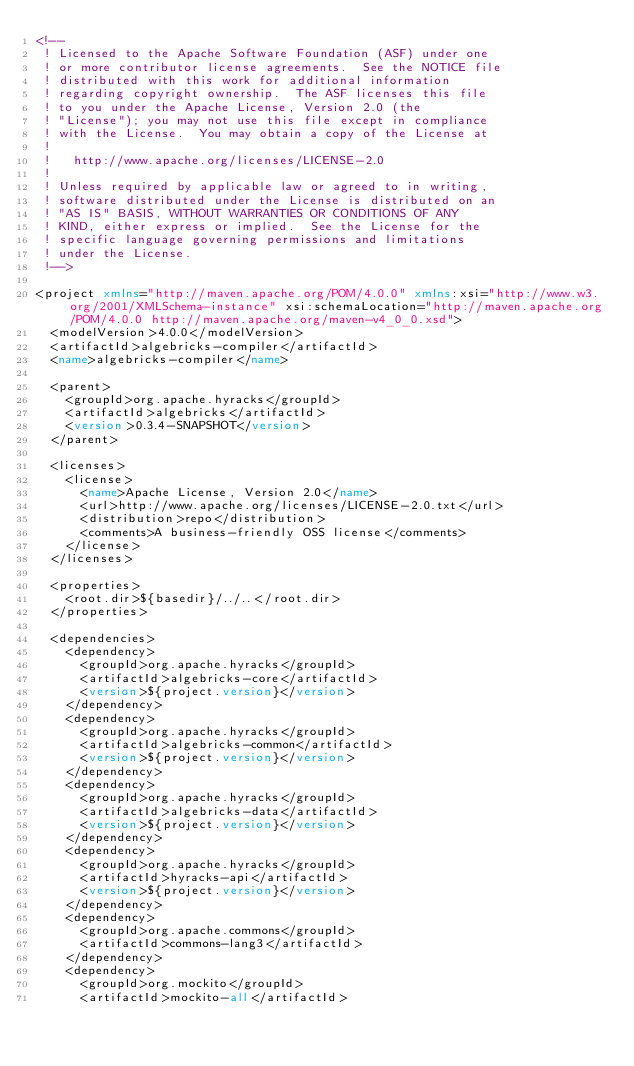Convert code to text. <code><loc_0><loc_0><loc_500><loc_500><_XML_><!--
 ! Licensed to the Apache Software Foundation (ASF) under one
 ! or more contributor license agreements.  See the NOTICE file
 ! distributed with this work for additional information
 ! regarding copyright ownership.  The ASF licenses this file
 ! to you under the Apache License, Version 2.0 (the
 ! "License"); you may not use this file except in compliance
 ! with the License.  You may obtain a copy of the License at
 !
 !   http://www.apache.org/licenses/LICENSE-2.0
 !
 ! Unless required by applicable law or agreed to in writing,
 ! software distributed under the License is distributed on an
 ! "AS IS" BASIS, WITHOUT WARRANTIES OR CONDITIONS OF ANY
 ! KIND, either express or implied.  See the License for the
 ! specific language governing permissions and limitations
 ! under the License.
 !-->

<project xmlns="http://maven.apache.org/POM/4.0.0" xmlns:xsi="http://www.w3.org/2001/XMLSchema-instance" xsi:schemaLocation="http://maven.apache.org/POM/4.0.0 http://maven.apache.org/maven-v4_0_0.xsd">
  <modelVersion>4.0.0</modelVersion>
  <artifactId>algebricks-compiler</artifactId>
  <name>algebricks-compiler</name>

  <parent>
    <groupId>org.apache.hyracks</groupId>
    <artifactId>algebricks</artifactId>
    <version>0.3.4-SNAPSHOT</version>
  </parent>

  <licenses>
    <license>
      <name>Apache License, Version 2.0</name>
      <url>http://www.apache.org/licenses/LICENSE-2.0.txt</url>
      <distribution>repo</distribution>
      <comments>A business-friendly OSS license</comments>
    </license>
  </licenses>

  <properties>
    <root.dir>${basedir}/../..</root.dir>
  </properties>

  <dependencies>
    <dependency>
      <groupId>org.apache.hyracks</groupId>
      <artifactId>algebricks-core</artifactId>
      <version>${project.version}</version>
    </dependency>
    <dependency>
      <groupId>org.apache.hyracks</groupId>
      <artifactId>algebricks-common</artifactId>
      <version>${project.version}</version>
    </dependency>
    <dependency>
      <groupId>org.apache.hyracks</groupId>
      <artifactId>algebricks-data</artifactId>
      <version>${project.version}</version>
    </dependency>
    <dependency>
      <groupId>org.apache.hyracks</groupId>
      <artifactId>hyracks-api</artifactId>
      <version>${project.version}</version>
    </dependency>
    <dependency>
      <groupId>org.apache.commons</groupId>
      <artifactId>commons-lang3</artifactId>
    </dependency>
    <dependency>
      <groupId>org.mockito</groupId>
      <artifactId>mockito-all</artifactId></code> 